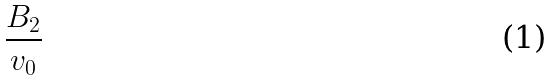Convert formula to latex. <formula><loc_0><loc_0><loc_500><loc_500>\frac { B _ { 2 } } { v _ { 0 } }</formula> 